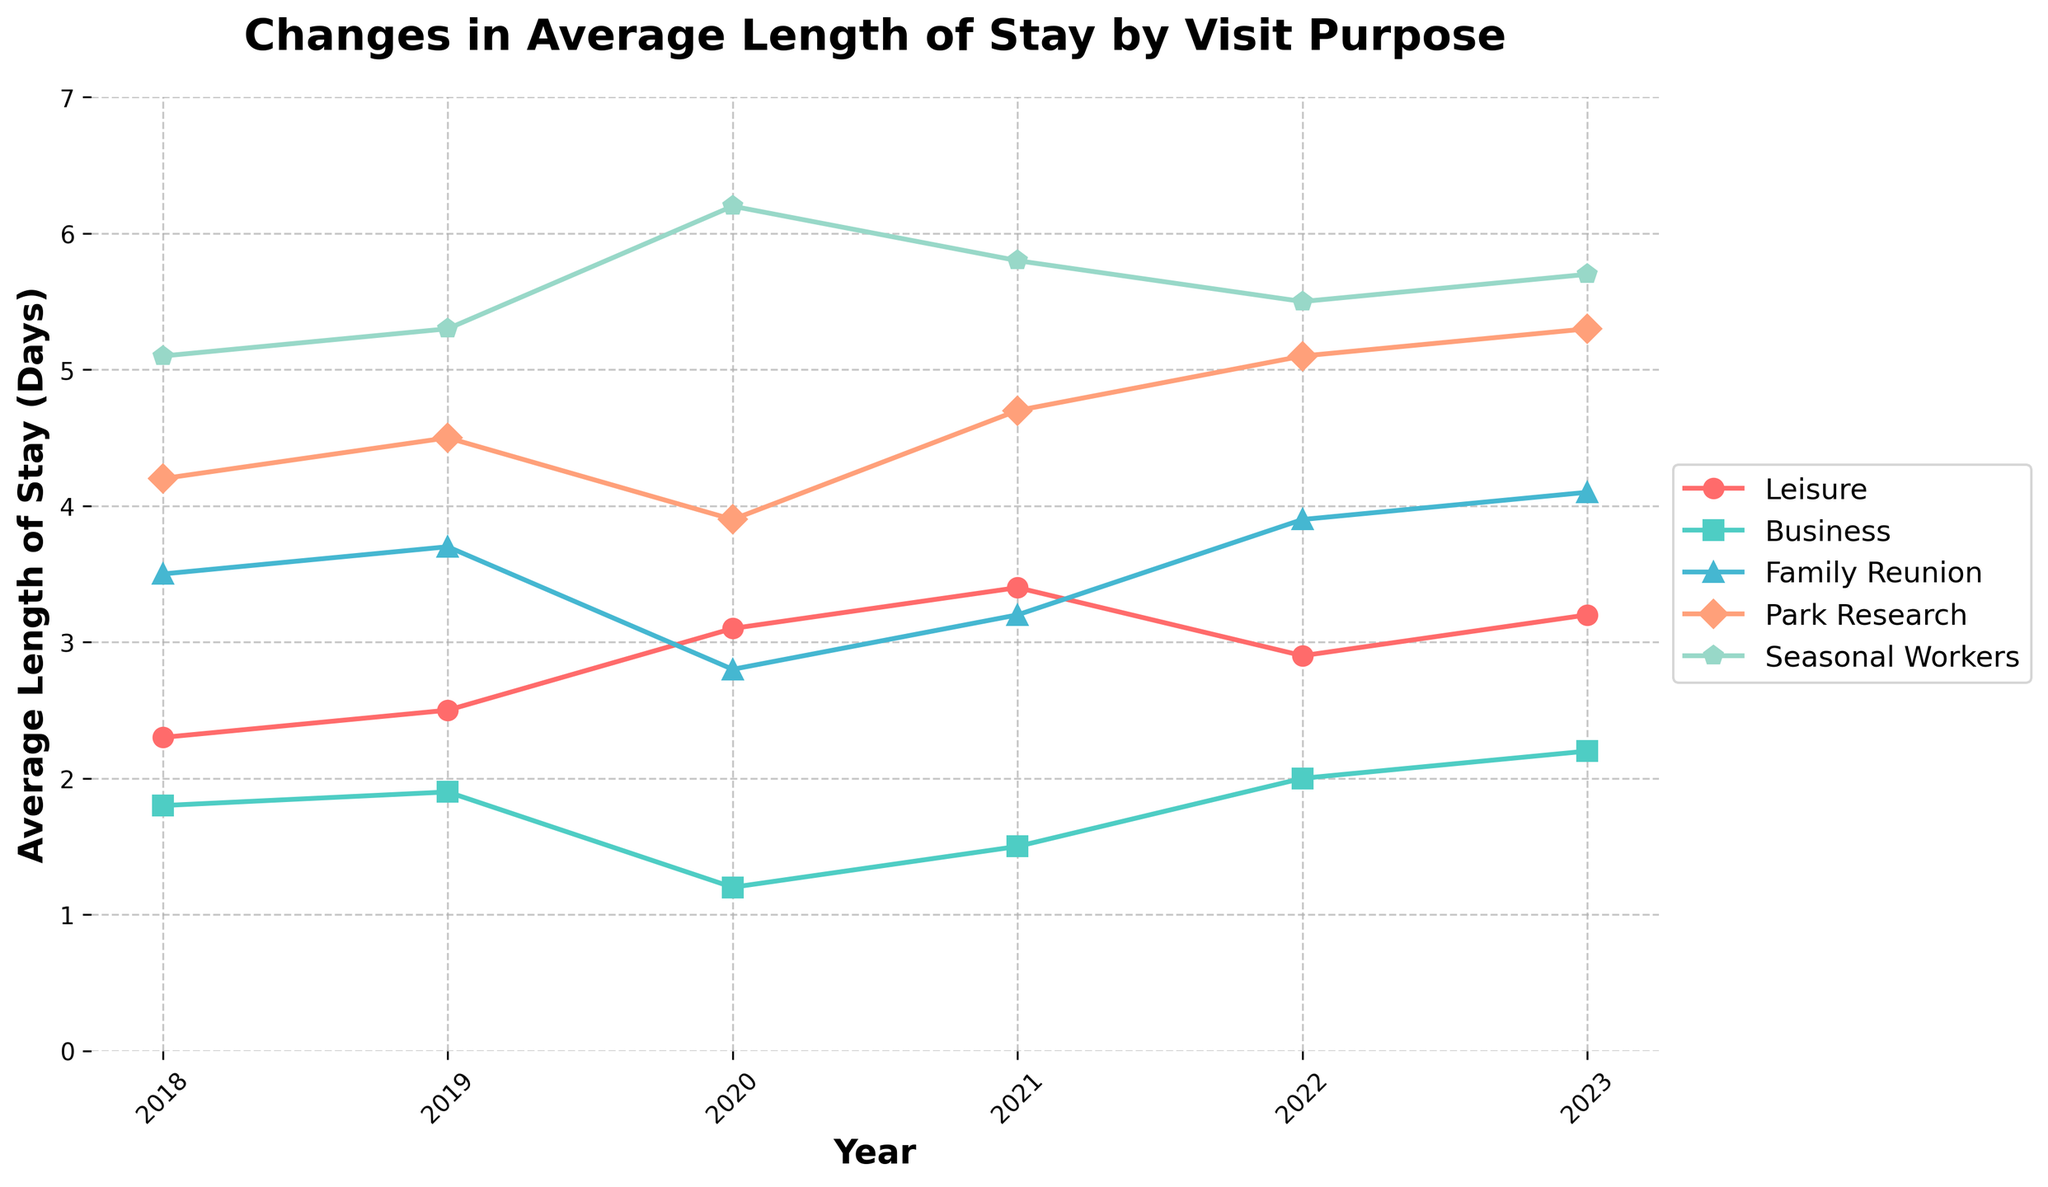What is the average length of stay for leisure travelers in 2021? To find the answer, locate the 'Leisure' line on the chart for the year 2021. The y-axis value corresponding to this point is the average length of stay for leisure travelers in 2021.
Answer: 3.4 Which visit purpose experienced the greatest increase in average length of stay from 2019 to 2020? Identify the differences for each category between 2019 and 2020 by calculating the difference between the two years' data points. The category with the greatest positive difference is the answer. For 'Leisure', the increase is 3.1 - 2.5 = 0.6; for 'Business', 1.2 - 1.9 = -0.7; for 'Family Reunion', 2.8 - 3.7 = -0.9; for 'Park Research', 3.9 - 4.5 = -0.6; for 'Seasonal Workers', 6.2 - 5.3 = 0.9.
Answer: Seasonal Workers How did the average length of stay for business travelers change from 2020 to 2023? Locate the 'Business' line and compare the 2020 value with the 2023 value. The difference between these two values is the change in average length of stay. The values are 1.2 (2020) and 2.2 (2023), giving a difference of 2.2 - 1.2.
Answer: 1.0 Between 2022 and 2023, which category had the smallest change in average length of stay? For each category, subtract the 2022 value from the 2023 value. Identify the category with the smallest absolute difference. For 'Leisure', the change is 3.2 - 2.9 = 0.3; for 'Business', 2.2 - 2.0 = 0.2; for 'Family Reunion', 4.1 - 3.9 = 0.2; for 'Park Research', 5.3 - 5.1 = 0.2; for 'Seasonal Workers', 5.7 - 5.5 = 0.2. The smallest change of 0.2 is shared by 'Business', 'Family Reunion', 'Park Research', and 'Seasonal Workers'.
Answer: Business, Family Reunion, Park Research, and Seasonal Workers Compare the change in average length of stay for park researchers between 2018 and 2023 with that of family reunions over the same period. Which one had a larger increase? For 'Park Research', the change from 2018 to 2023 is 5.3 - 4.2 = 1.1 days. For 'Family Reunion', the change from 2018 to 2023 is 4.1 - 3.5 = 0.6 days. Thus, park researchers had a larger increase.
Answer: Park Research What was the trend in average length of stay for seasonal workers from 2018 to 2023? Observe the 'Seasonal Workers' line from 2018 to 2023. Throughout these years, the values sequentially increase from 5.1 to 5.3, then to 6.2, decrease to 5.8, and slightly decline to 5.5, and slightly increase again to 5.7. The overall trend shows minor fluctuations with a general upward movement.
Answer: Upward with minor fluctuations Which purpose of visit had the highest average length of stay in 2023? Identify the points for each category in 2023 and find the highest y-axis value. The 'Seasonal Workers' category shows the highest average length of stay with a value of 5.7 days.
Answer: Seasonal Workers Between 2019 and 2021, how did the average length of stay for leisure travelers change, and what was the total increase? Calculate the differences year by year for 'Leisure' from 2019 through 2021. From 2019 to 2020, the change is 3.1 - 2.5 = 0.6 days, and from 2020 to 2021, it is 3.4 - 3.1 = 0.3 days. The total increase from 2019 to 2021 is 0.6 + 0.3 = 0.9 days.
Answer: 0.9 What year had the lowest average length of stay for business travelers and what was the value? Locate the minimum point on the 'Business' line and find the corresponding year and value. The lowest point is in 2020 with a value of 1.2 days.
Answer: 2020, 1.2 